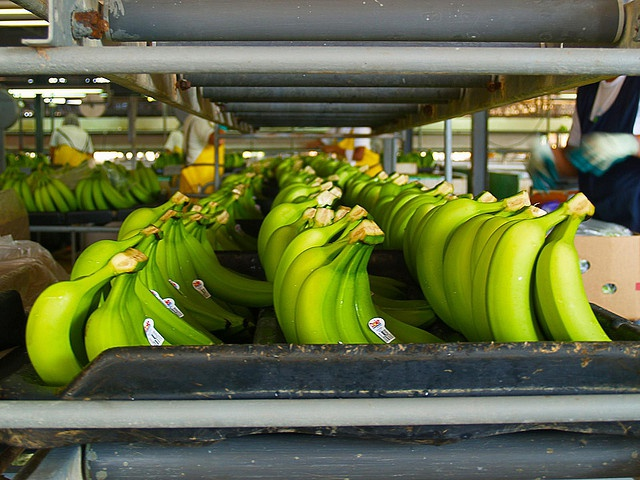Describe the objects in this image and their specific colors. I can see banana in gray, darkgreen, black, and olive tones, people in gray, black, teal, and lightgray tones, banana in gray, khaki, olive, and yellow tones, banana in gray, black, darkgreen, and olive tones, and banana in gray, khaki, yellow, and olive tones in this image. 